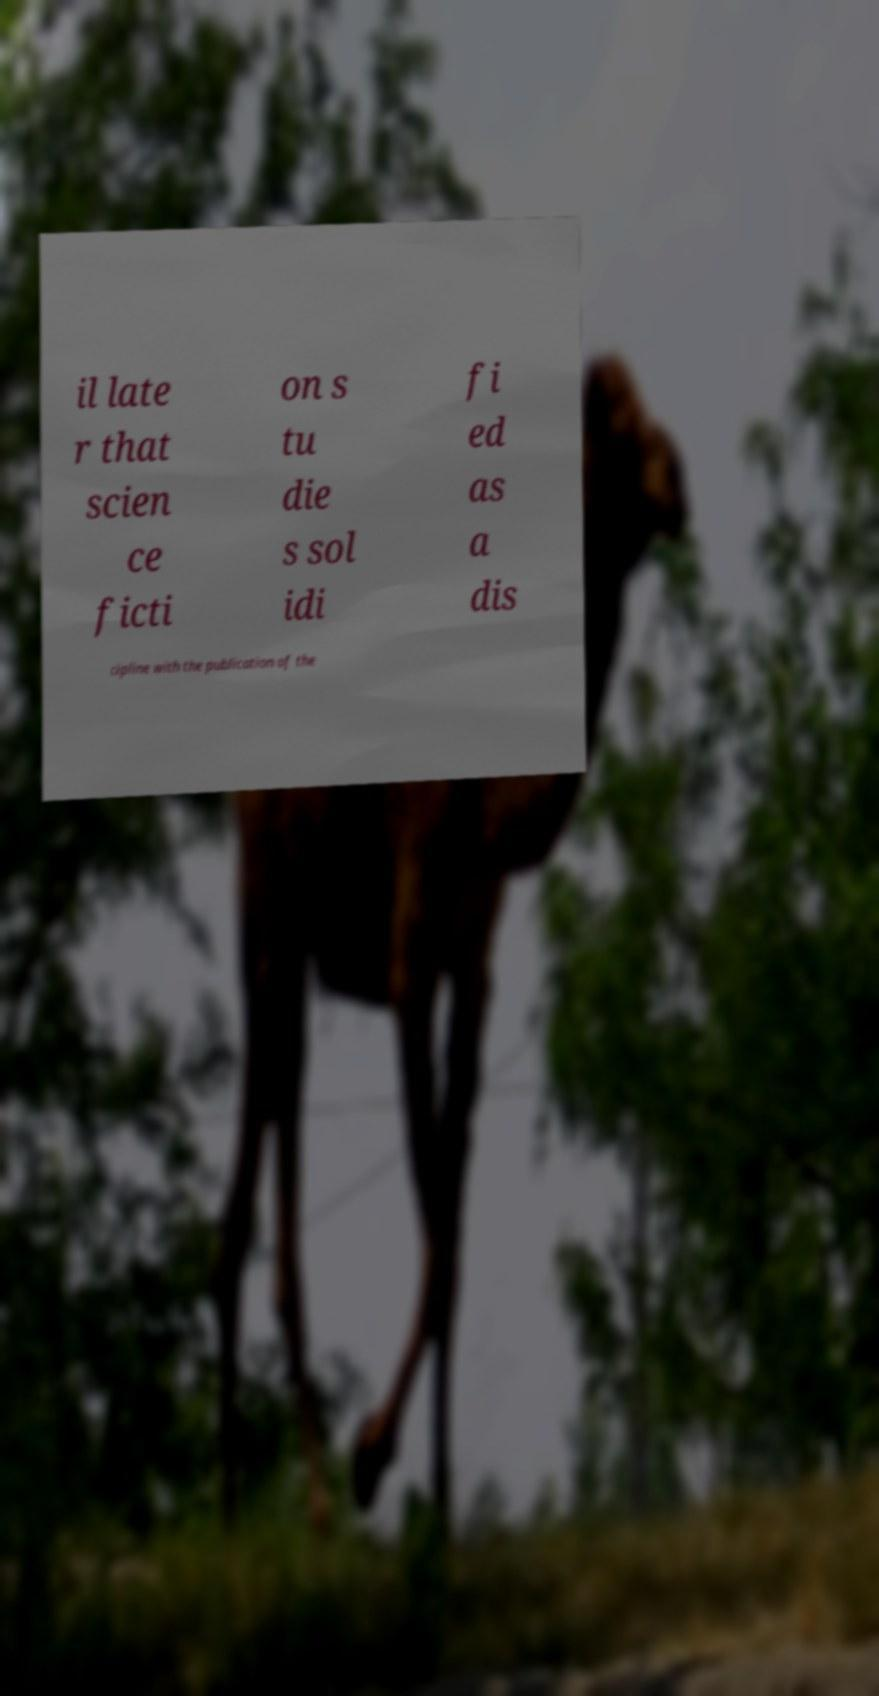Could you extract and type out the text from this image? il late r that scien ce ficti on s tu die s sol idi fi ed as a dis cipline with the publication of the 